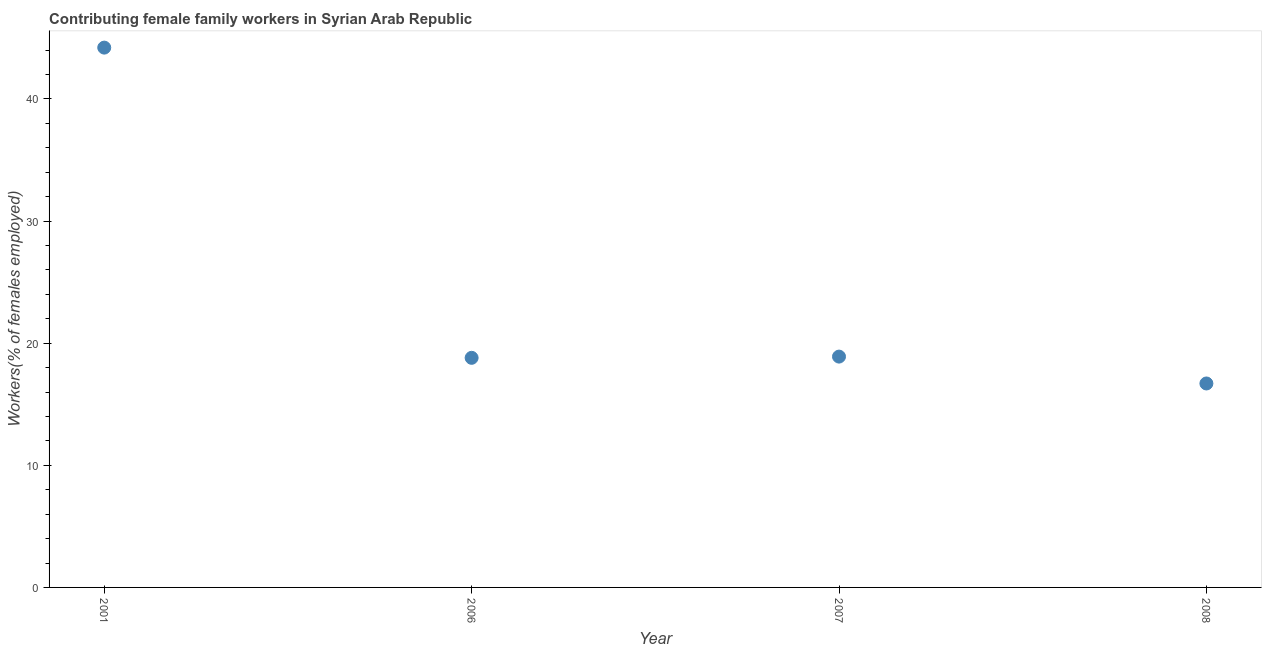What is the contributing female family workers in 2008?
Provide a short and direct response. 16.7. Across all years, what is the maximum contributing female family workers?
Provide a short and direct response. 44.2. Across all years, what is the minimum contributing female family workers?
Make the answer very short. 16.7. What is the sum of the contributing female family workers?
Your answer should be very brief. 98.6. What is the difference between the contributing female family workers in 2006 and 2008?
Make the answer very short. 2.1. What is the average contributing female family workers per year?
Provide a succinct answer. 24.65. What is the median contributing female family workers?
Offer a terse response. 18.85. In how many years, is the contributing female family workers greater than 28 %?
Provide a succinct answer. 1. Do a majority of the years between 2007 and 2008 (inclusive) have contributing female family workers greater than 2 %?
Provide a short and direct response. Yes. What is the ratio of the contributing female family workers in 2001 to that in 2007?
Ensure brevity in your answer.  2.34. Is the difference between the contributing female family workers in 2006 and 2007 greater than the difference between any two years?
Keep it short and to the point. No. What is the difference between the highest and the second highest contributing female family workers?
Your response must be concise. 25.3. What is the difference between the highest and the lowest contributing female family workers?
Your answer should be compact. 27.5. How many years are there in the graph?
Ensure brevity in your answer.  4. Does the graph contain any zero values?
Keep it short and to the point. No. What is the title of the graph?
Offer a terse response. Contributing female family workers in Syrian Arab Republic. What is the label or title of the Y-axis?
Offer a terse response. Workers(% of females employed). What is the Workers(% of females employed) in 2001?
Your answer should be very brief. 44.2. What is the Workers(% of females employed) in 2006?
Keep it short and to the point. 18.8. What is the Workers(% of females employed) in 2007?
Offer a terse response. 18.9. What is the Workers(% of females employed) in 2008?
Ensure brevity in your answer.  16.7. What is the difference between the Workers(% of females employed) in 2001 and 2006?
Keep it short and to the point. 25.4. What is the difference between the Workers(% of females employed) in 2001 and 2007?
Keep it short and to the point. 25.3. What is the difference between the Workers(% of females employed) in 2006 and 2008?
Offer a terse response. 2.1. What is the ratio of the Workers(% of females employed) in 2001 to that in 2006?
Your answer should be very brief. 2.35. What is the ratio of the Workers(% of females employed) in 2001 to that in 2007?
Keep it short and to the point. 2.34. What is the ratio of the Workers(% of females employed) in 2001 to that in 2008?
Your answer should be very brief. 2.65. What is the ratio of the Workers(% of females employed) in 2006 to that in 2007?
Offer a terse response. 0.99. What is the ratio of the Workers(% of females employed) in 2006 to that in 2008?
Keep it short and to the point. 1.13. What is the ratio of the Workers(% of females employed) in 2007 to that in 2008?
Ensure brevity in your answer.  1.13. 